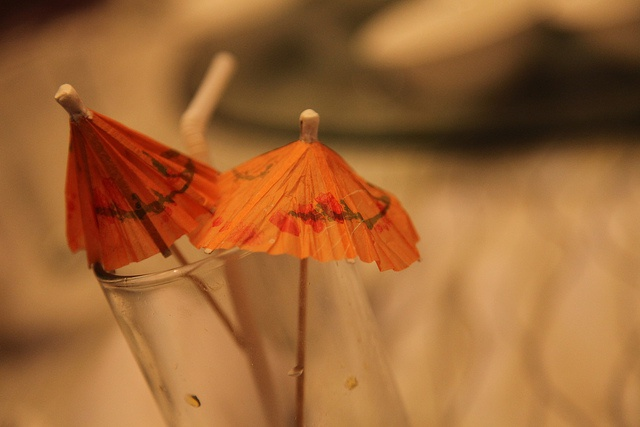Describe the objects in this image and their specific colors. I can see cup in black, brown, and tan tones, umbrella in black, maroon, brown, and red tones, and umbrella in black, red, and brown tones in this image. 